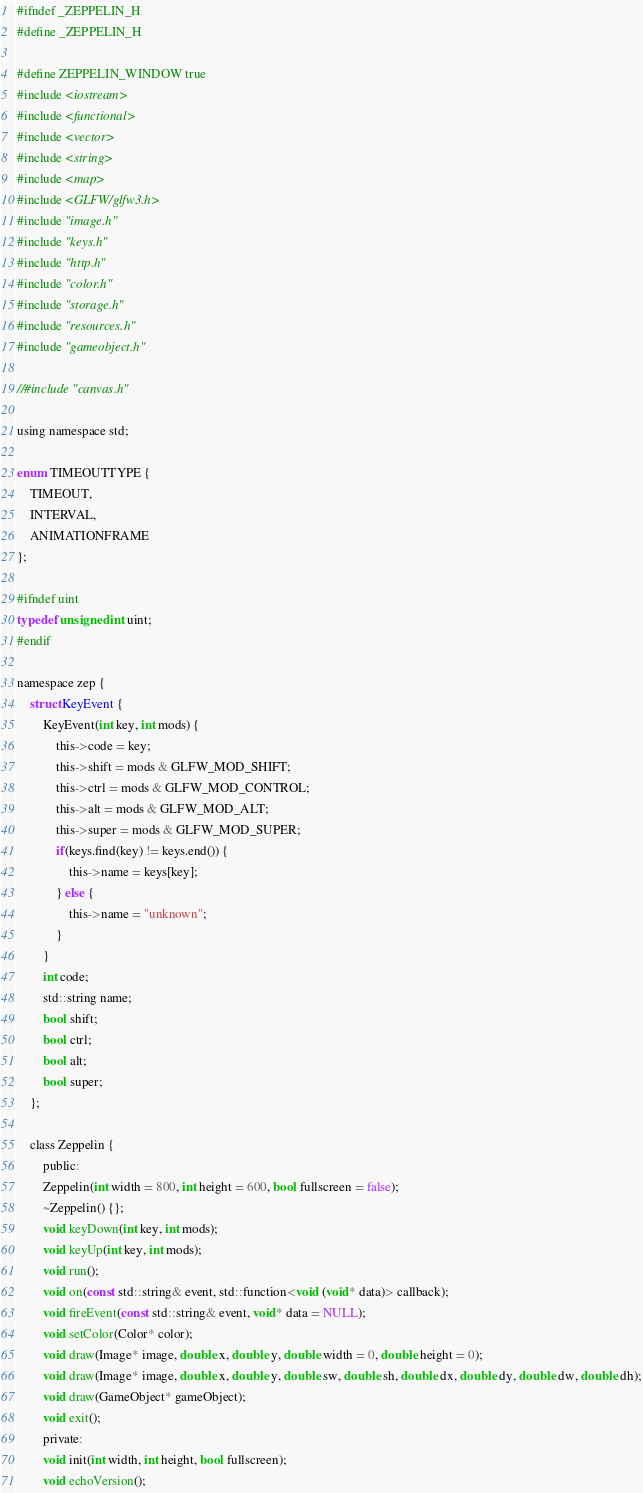Convert code to text. <code><loc_0><loc_0><loc_500><loc_500><_C_>#ifndef _ZEPPELIN_H
#define _ZEPPELIN_H

#define ZEPPELIN_WINDOW true
#include <iostream>
#include <functional>
#include <vector>
#include <string>
#include <map>
#include <GLFW/glfw3.h>
#include "image.h"
#include "keys.h"
#include "http.h"
#include "color.h"
#include "storage.h"
#include "resources.h"
#include "gameobject.h"

//#include "canvas.h"

using namespace std;

enum TIMEOUTTYPE {
	TIMEOUT,
	INTERVAL,
	ANIMATIONFRAME
};

#ifndef uint
typedef unsigned int uint;
#endif

namespace zep {
    struct KeyEvent {
        KeyEvent(int key, int mods) {
            this->code = key;
            this->shift = mods & GLFW_MOD_SHIFT;
            this->ctrl = mods & GLFW_MOD_CONTROL;
            this->alt = mods & GLFW_MOD_ALT;
            this->super = mods & GLFW_MOD_SUPER;
            if(keys.find(key) != keys.end()) {
                this->name = keys[key];
            } else {
                this->name = "unknown";
            }
        }
        int code;
        std::string name;
        bool shift;
        bool ctrl;
        bool alt;
        bool super;
    };

    class Zeppelin {
        public:
        Zeppelin(int width = 800, int height = 600, bool fullscreen = false);
        ~Zeppelin() {};
        void keyDown(int key, int mods);
        void keyUp(int key, int mods);
        void run();
        void on(const std::string& event, std::function<void (void* data)> callback);
        void fireEvent(const std::string& event, void* data = NULL);
        void setColor(Color* color);
        void draw(Image* image, double x, double y, double width = 0, double height = 0);
        void draw(Image* image, double x, double y, double sw, double sh, double dx, double dy, double dw, double dh);
		void draw(GameObject* gameObject);
        void exit();
        private:
        void init(int width, int height, bool fullscreen);
        void echoVersion();</code> 